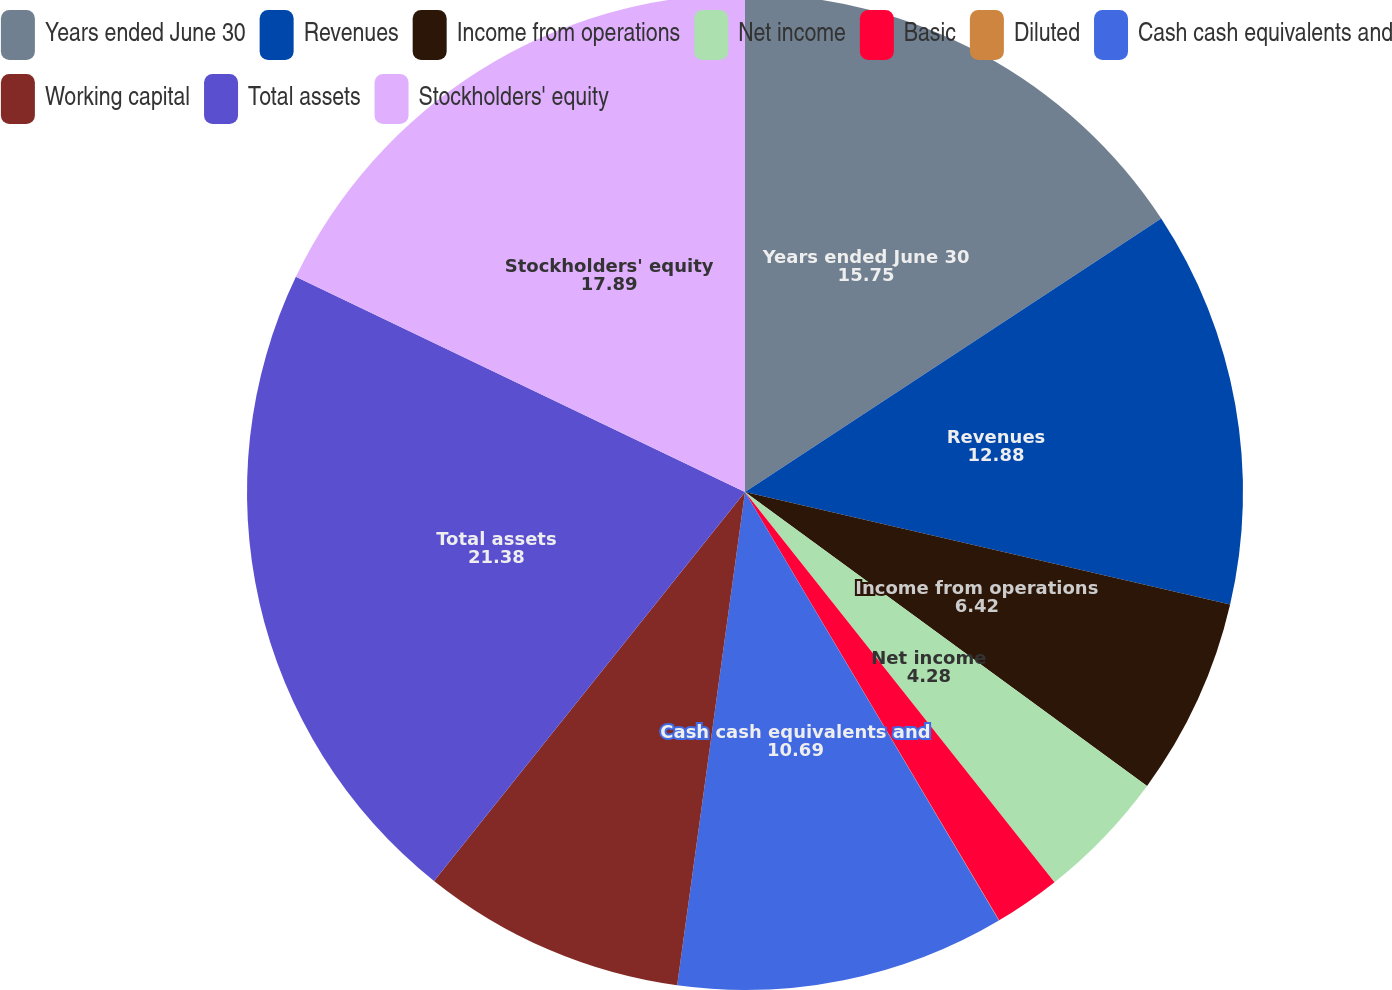Convert chart. <chart><loc_0><loc_0><loc_500><loc_500><pie_chart><fcel>Years ended June 30<fcel>Revenues<fcel>Income from operations<fcel>Net income<fcel>Basic<fcel>Diluted<fcel>Cash cash equivalents and<fcel>Working capital<fcel>Total assets<fcel>Stockholders' equity<nl><fcel>15.75%<fcel>12.88%<fcel>6.42%<fcel>4.28%<fcel>2.15%<fcel>0.01%<fcel>10.69%<fcel>8.56%<fcel>21.38%<fcel>17.89%<nl></chart> 